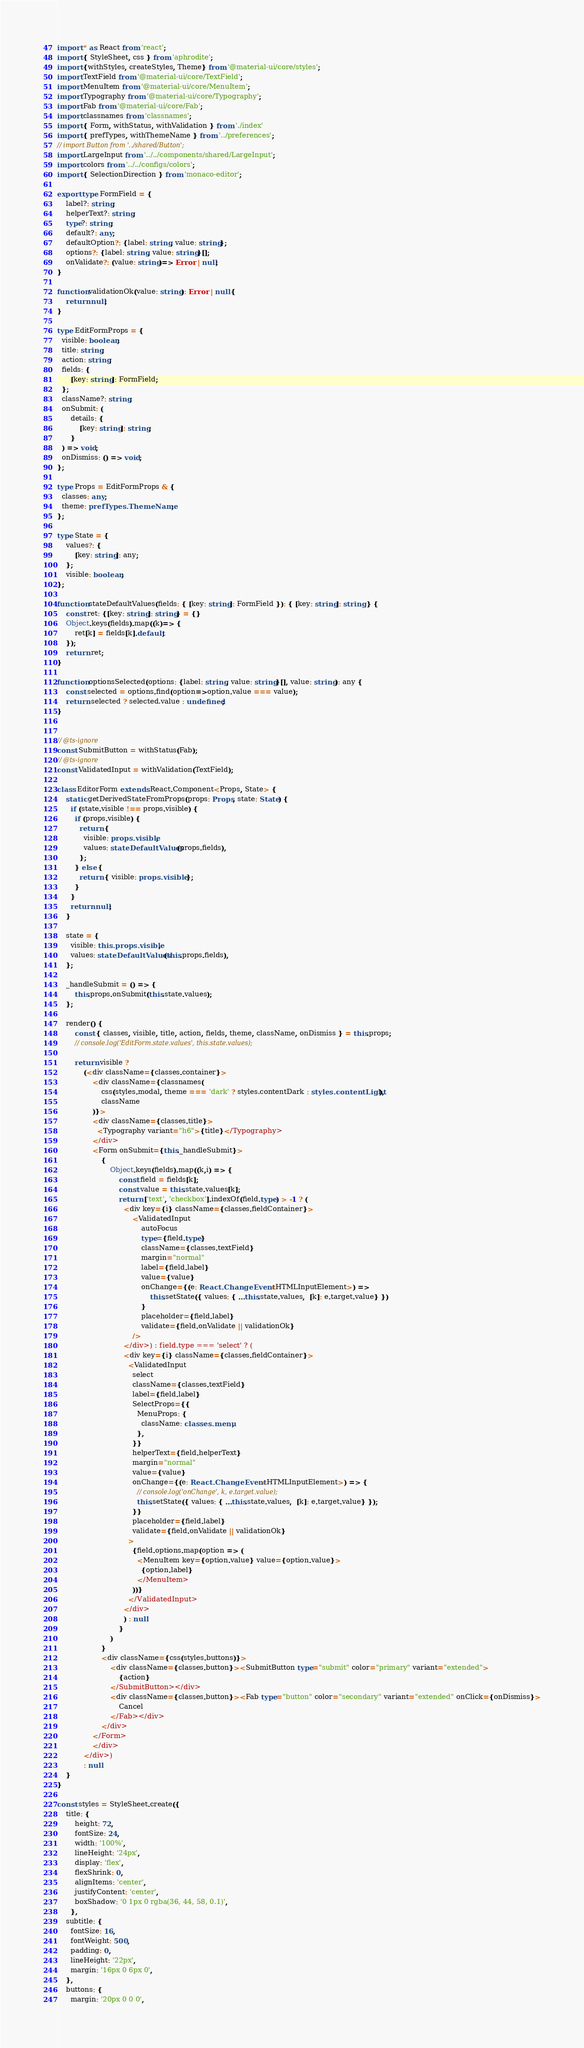Convert code to text. <code><loc_0><loc_0><loc_500><loc_500><_TypeScript_>import * as React from 'react';
import { StyleSheet, css } from 'aphrodite';
import {withStyles, createStyles, Theme} from '@material-ui/core/styles';
import TextField from '@material-ui/core/TextField';
import MenuItem from '@material-ui/core/MenuItem';
import Typography from '@material-ui/core/Typography';
import Fab from '@material-ui/core/Fab';
import classnames from 'classnames';
import { Form, withStatus, withValidation } from './index'
import { prefTypes, withThemeName } from '../preferences';
// import Button from '../shared/Button';
import LargeInput from '../../components/shared/LargeInput';
import colors from '../../configs/colors';
import { SelectionDirection } from 'monaco-editor';

export type FormField = {
    label?: string;
    helperText?: string;
    type?: string;
    default?: any;
    defaultOption?: {label: string, value: string};
    options?: {label: string, value: string}[];
    onValidate?: (value: string)=> Error | null;
}

function validationOk(value: string): Error | null {
    return null;
}

type EditFormProps = {
  visible: boolean;
  title: string;
  action: string;
  fields: {
      [key: string]: FormField;
  };
  className?: string;
  onSubmit: (
      details: {
          [key: string]: string;
      }
  ) => void;
  onDismiss: () => void;
};

type Props = EditFormProps & {
  classes: any;
  theme: prefTypes.ThemeName;
};

type State = {
    values?: {
        [key: string]: any;
    };
    visible: boolean;
};

function stateDefaultValues(fields: { [key: string]: FormField }): { [key: string]: string } {
    const ret: {[key: string]: string} = {}
    Object.keys(fields).map((k)=> {
        ret[k] = fields[k].default;
    });
    return ret;
}

function optionsSelected(options: {label: string, value: string}[], value: string): any {
    const selected = options.find(option=>option.value === value);
    return selected ? selected.value : undefined;
}


// @ts-ignore
const SubmitButton = withStatus(Fab);
// @ts-ignore
const ValidatedInput = withValidation(TextField);

class EditorForm extends React.Component<Props, State> {
    static getDerivedStateFromProps(props: Props, state: State) {
      if (state.visible !== props.visible) {
        if (props.visible) {
          return {
            visible: props.visible,
            values: stateDefaultValues(props.fields),
          };
        } else {
          return { visible: props.visible };
        }
      }
      return null;
    }
    
    state = {
      visible: this.props.visible,
      values: stateDefaultValues(this.props.fields),
    };
    
    _handleSubmit = () => {
        this.props.onSubmit(this.state.values);
    };

    render() {
        const { classes, visible, title, action, fields, theme, className, onDismiss } = this.props;
        // console.log('EditForm.state.values', this.state.values);
    
        return visible ?
            (<div className={classes.container}>
                <div className={classnames(
                    css(styles.modal, theme === 'dark' ? styles.contentDark : styles.contentLight),
                    className
                )}>
                <div className={classes.title}>
                  <Typography variant="h6">{title}</Typography>
                </div>
                <Form onSubmit={this._handleSubmit}>
                    {
                        Object.keys(fields).map((k,i) => {
                            const field = fields[k];
                            const value = this.state.values[k];
                            return ['text', 'checkbox'].indexOf(field.type) > -1 ? (
                              <div key={i} className={classes.fieldContainer}>
                                  <ValidatedInput
                                      autoFocus
                                      type={field.type}
                                      className={classes.textField}
                                      margin="normal"
                                      label={field.label}
                                      value={value}
                                      onChange={(e: React.ChangeEvent<HTMLInputElement>) =>
                                          this.setState({ values: { ...this.state.values,  [k]: e.target.value} })
                                      }
                                      placeholder={field.label}
                                      validate={field.onValidate || validationOk}
                                  />
                              </div>) : field.type === 'select' ? (
                              <div key={i} className={classes.fieldContainer}>
                                <ValidatedInput        
                                  select
                                  className={classes.textField}
                                  label={field.label}
                                  SelectProps={{
                                    MenuProps: {
                                      className: classes.menu,
                                    },
                                  }}
                                  helperText={field.helperText}
                                  margin="normal"
                                  value={value}
                                  onChange={(e: React.ChangeEvent<HTMLInputElement>) => {
                                    // console.log('onChange', k, e.target.value);
                                    this.setState({ values: { ...this.state.values,  [k]: e.target.value} });
                                  }}
                                  placeholder={field.label}
                                  validate={field.onValidate || validationOk}
                                >
                                  {field.options.map(option => (
                                    <MenuItem key={option.value} value={option.value}>
                                      {option.label}
                                    </MenuItem>
                                  ))}
                                </ValidatedInput>                                
                              </div>
                              ) : null
                            }
                        )
                    }
                    <div className={css(styles.buttons)}>
                        <div className={classes.button}><SubmitButton type="submit" color="primary" variant="extended">
                            {action}
                        </SubmitButton></div>
                        <div className={classes.button}><Fab type="button" color="secondary" variant="extended" onClick={onDismiss}>
                            Cancel
                        </Fab></div>
                    </div>
                </Form>
                </div>
            </div>)
            : null
    }
}

const styles = StyleSheet.create({
    title: {
        height: 72,
        fontSize: 24,
        width: '100%',
        lineHeight: '24px',
        display: 'flex',
        flexShrink: 0,
        alignItems: 'center',
        justifyContent: 'center',
        boxShadow: '0 1px 0 rgba(36, 44, 58, 0.1)',
      },
    subtitle: {
      fontSize: 16,
      fontWeight: 500,
      padding: 0,
      lineHeight: '22px',
      margin: '16px 0 6px 0',
    },
    buttons: {
      margin: '20px 0 0 0',</code> 